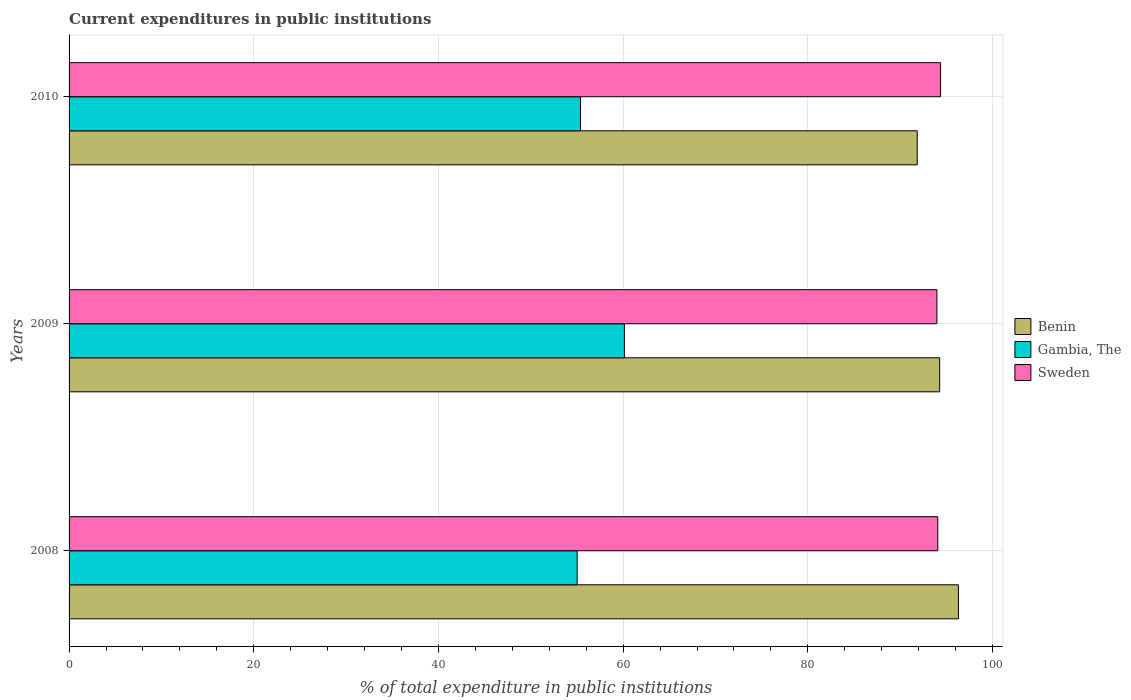How many different coloured bars are there?
Offer a terse response. 3. Are the number of bars per tick equal to the number of legend labels?
Your response must be concise. Yes. What is the current expenditures in public institutions in Sweden in 2010?
Offer a terse response. 94.38. Across all years, what is the maximum current expenditures in public institutions in Gambia, The?
Provide a succinct answer. 60.14. Across all years, what is the minimum current expenditures in public institutions in Benin?
Your answer should be compact. 91.85. In which year was the current expenditures in public institutions in Sweden maximum?
Provide a short and direct response. 2010. In which year was the current expenditures in public institutions in Sweden minimum?
Offer a very short reply. 2009. What is the total current expenditures in public institutions in Benin in the graph?
Your response must be concise. 282.44. What is the difference between the current expenditures in public institutions in Benin in 2008 and that in 2010?
Provide a succinct answer. 4.46. What is the difference between the current expenditures in public institutions in Sweden in 2009 and the current expenditures in public institutions in Gambia, The in 2008?
Your response must be concise. 38.96. What is the average current expenditures in public institutions in Sweden per year?
Offer a very short reply. 94.15. In the year 2009, what is the difference between the current expenditures in public institutions in Gambia, The and current expenditures in public institutions in Sweden?
Offer a very short reply. -33.84. What is the ratio of the current expenditures in public institutions in Sweden in 2008 to that in 2009?
Keep it short and to the point. 1. Is the current expenditures in public institutions in Gambia, The in 2008 less than that in 2010?
Keep it short and to the point. Yes. What is the difference between the highest and the second highest current expenditures in public institutions in Benin?
Ensure brevity in your answer.  2.03. What is the difference between the highest and the lowest current expenditures in public institutions in Gambia, The?
Provide a short and direct response. 5.11. What does the 1st bar from the top in 2010 represents?
Provide a succinct answer. Sweden. Is it the case that in every year, the sum of the current expenditures in public institutions in Sweden and current expenditures in public institutions in Gambia, The is greater than the current expenditures in public institutions in Benin?
Offer a very short reply. Yes. Are the values on the major ticks of X-axis written in scientific E-notation?
Your answer should be very brief. No. Does the graph contain any zero values?
Make the answer very short. No. What is the title of the graph?
Ensure brevity in your answer.  Current expenditures in public institutions. Does "Nigeria" appear as one of the legend labels in the graph?
Ensure brevity in your answer.  No. What is the label or title of the X-axis?
Offer a very short reply. % of total expenditure in public institutions. What is the % of total expenditure in public institutions in Benin in 2008?
Offer a terse response. 96.31. What is the % of total expenditure in public institutions in Gambia, The in 2008?
Your response must be concise. 55.02. What is the % of total expenditure in public institutions in Sweden in 2008?
Your response must be concise. 94.08. What is the % of total expenditure in public institutions of Benin in 2009?
Make the answer very short. 94.28. What is the % of total expenditure in public institutions of Gambia, The in 2009?
Give a very brief answer. 60.14. What is the % of total expenditure in public institutions in Sweden in 2009?
Offer a very short reply. 93.98. What is the % of total expenditure in public institutions in Benin in 2010?
Your answer should be compact. 91.85. What is the % of total expenditure in public institutions in Gambia, The in 2010?
Provide a succinct answer. 55.38. What is the % of total expenditure in public institutions in Sweden in 2010?
Offer a terse response. 94.38. Across all years, what is the maximum % of total expenditure in public institutions in Benin?
Make the answer very short. 96.31. Across all years, what is the maximum % of total expenditure in public institutions in Gambia, The?
Your response must be concise. 60.14. Across all years, what is the maximum % of total expenditure in public institutions of Sweden?
Provide a succinct answer. 94.38. Across all years, what is the minimum % of total expenditure in public institutions in Benin?
Give a very brief answer. 91.85. Across all years, what is the minimum % of total expenditure in public institutions of Gambia, The?
Offer a terse response. 55.02. Across all years, what is the minimum % of total expenditure in public institutions of Sweden?
Offer a very short reply. 93.98. What is the total % of total expenditure in public institutions of Benin in the graph?
Ensure brevity in your answer.  282.44. What is the total % of total expenditure in public institutions in Gambia, The in the graph?
Your answer should be compact. 170.54. What is the total % of total expenditure in public institutions of Sweden in the graph?
Ensure brevity in your answer.  282.44. What is the difference between the % of total expenditure in public institutions of Benin in 2008 and that in 2009?
Keep it short and to the point. 2.03. What is the difference between the % of total expenditure in public institutions of Gambia, The in 2008 and that in 2009?
Your response must be concise. -5.11. What is the difference between the % of total expenditure in public institutions in Sweden in 2008 and that in 2009?
Provide a succinct answer. 0.1. What is the difference between the % of total expenditure in public institutions in Benin in 2008 and that in 2010?
Ensure brevity in your answer.  4.46. What is the difference between the % of total expenditure in public institutions in Gambia, The in 2008 and that in 2010?
Keep it short and to the point. -0.36. What is the difference between the % of total expenditure in public institutions in Sweden in 2008 and that in 2010?
Offer a very short reply. -0.3. What is the difference between the % of total expenditure in public institutions in Benin in 2009 and that in 2010?
Your answer should be compact. 2.43. What is the difference between the % of total expenditure in public institutions in Gambia, The in 2009 and that in 2010?
Provide a short and direct response. 4.75. What is the difference between the % of total expenditure in public institutions in Sweden in 2009 and that in 2010?
Your answer should be very brief. -0.4. What is the difference between the % of total expenditure in public institutions in Benin in 2008 and the % of total expenditure in public institutions in Gambia, The in 2009?
Offer a very short reply. 36.17. What is the difference between the % of total expenditure in public institutions in Benin in 2008 and the % of total expenditure in public institutions in Sweden in 2009?
Ensure brevity in your answer.  2.33. What is the difference between the % of total expenditure in public institutions of Gambia, The in 2008 and the % of total expenditure in public institutions of Sweden in 2009?
Provide a short and direct response. -38.96. What is the difference between the % of total expenditure in public institutions of Benin in 2008 and the % of total expenditure in public institutions of Gambia, The in 2010?
Keep it short and to the point. 40.93. What is the difference between the % of total expenditure in public institutions of Benin in 2008 and the % of total expenditure in public institutions of Sweden in 2010?
Your answer should be compact. 1.93. What is the difference between the % of total expenditure in public institutions in Gambia, The in 2008 and the % of total expenditure in public institutions in Sweden in 2010?
Your answer should be very brief. -39.36. What is the difference between the % of total expenditure in public institutions of Benin in 2009 and the % of total expenditure in public institutions of Gambia, The in 2010?
Your response must be concise. 38.9. What is the difference between the % of total expenditure in public institutions in Benin in 2009 and the % of total expenditure in public institutions in Sweden in 2010?
Your response must be concise. -0.1. What is the difference between the % of total expenditure in public institutions of Gambia, The in 2009 and the % of total expenditure in public institutions of Sweden in 2010?
Provide a succinct answer. -34.24. What is the average % of total expenditure in public institutions of Benin per year?
Provide a succinct answer. 94.15. What is the average % of total expenditure in public institutions in Gambia, The per year?
Provide a short and direct response. 56.85. What is the average % of total expenditure in public institutions of Sweden per year?
Ensure brevity in your answer.  94.15. In the year 2008, what is the difference between the % of total expenditure in public institutions in Benin and % of total expenditure in public institutions in Gambia, The?
Offer a very short reply. 41.29. In the year 2008, what is the difference between the % of total expenditure in public institutions of Benin and % of total expenditure in public institutions of Sweden?
Your answer should be very brief. 2.23. In the year 2008, what is the difference between the % of total expenditure in public institutions in Gambia, The and % of total expenditure in public institutions in Sweden?
Your answer should be compact. -39.05. In the year 2009, what is the difference between the % of total expenditure in public institutions in Benin and % of total expenditure in public institutions in Gambia, The?
Your answer should be very brief. 34.14. In the year 2009, what is the difference between the % of total expenditure in public institutions in Benin and % of total expenditure in public institutions in Sweden?
Offer a very short reply. 0.3. In the year 2009, what is the difference between the % of total expenditure in public institutions in Gambia, The and % of total expenditure in public institutions in Sweden?
Ensure brevity in your answer.  -33.84. In the year 2010, what is the difference between the % of total expenditure in public institutions of Benin and % of total expenditure in public institutions of Gambia, The?
Keep it short and to the point. 36.47. In the year 2010, what is the difference between the % of total expenditure in public institutions of Benin and % of total expenditure in public institutions of Sweden?
Ensure brevity in your answer.  -2.53. In the year 2010, what is the difference between the % of total expenditure in public institutions of Gambia, The and % of total expenditure in public institutions of Sweden?
Offer a very short reply. -39. What is the ratio of the % of total expenditure in public institutions in Benin in 2008 to that in 2009?
Your answer should be very brief. 1.02. What is the ratio of the % of total expenditure in public institutions in Gambia, The in 2008 to that in 2009?
Provide a short and direct response. 0.92. What is the ratio of the % of total expenditure in public institutions in Sweden in 2008 to that in 2009?
Your answer should be very brief. 1. What is the ratio of the % of total expenditure in public institutions of Benin in 2008 to that in 2010?
Offer a terse response. 1.05. What is the ratio of the % of total expenditure in public institutions in Benin in 2009 to that in 2010?
Your answer should be compact. 1.03. What is the ratio of the % of total expenditure in public institutions of Gambia, The in 2009 to that in 2010?
Offer a terse response. 1.09. What is the difference between the highest and the second highest % of total expenditure in public institutions of Benin?
Your response must be concise. 2.03. What is the difference between the highest and the second highest % of total expenditure in public institutions in Gambia, The?
Your response must be concise. 4.75. What is the difference between the highest and the second highest % of total expenditure in public institutions of Sweden?
Ensure brevity in your answer.  0.3. What is the difference between the highest and the lowest % of total expenditure in public institutions of Benin?
Make the answer very short. 4.46. What is the difference between the highest and the lowest % of total expenditure in public institutions of Gambia, The?
Your response must be concise. 5.11. What is the difference between the highest and the lowest % of total expenditure in public institutions of Sweden?
Keep it short and to the point. 0.4. 